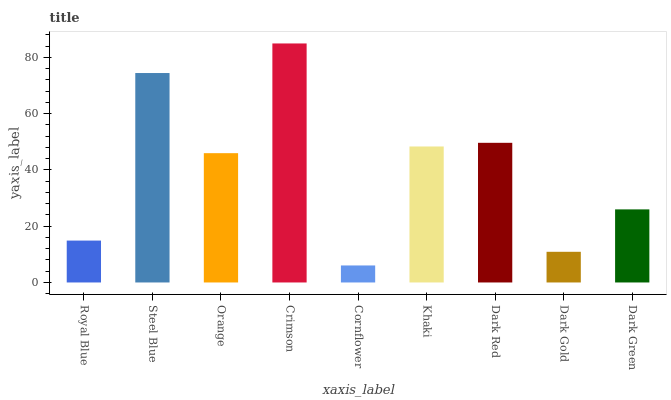Is Cornflower the minimum?
Answer yes or no. Yes. Is Crimson the maximum?
Answer yes or no. Yes. Is Steel Blue the minimum?
Answer yes or no. No. Is Steel Blue the maximum?
Answer yes or no. No. Is Steel Blue greater than Royal Blue?
Answer yes or no. Yes. Is Royal Blue less than Steel Blue?
Answer yes or no. Yes. Is Royal Blue greater than Steel Blue?
Answer yes or no. No. Is Steel Blue less than Royal Blue?
Answer yes or no. No. Is Orange the high median?
Answer yes or no. Yes. Is Orange the low median?
Answer yes or no. Yes. Is Cornflower the high median?
Answer yes or no. No. Is Steel Blue the low median?
Answer yes or no. No. 